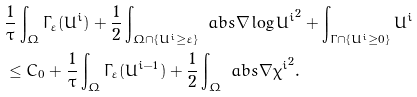Convert formula to latex. <formula><loc_0><loc_0><loc_500><loc_500>& \frac { 1 } { \tau } \int _ { \Omega } \Gamma _ { \varepsilon } ( U ^ { i } ) + \frac { 1 } { 2 } \int _ { \Omega \cap \{ U ^ { i } \geq \varepsilon \} } \ a b s { \nabla \log U ^ { i } } ^ { 2 } + \int _ { \Gamma \cap \{ U ^ { i } \geq 0 \} } U ^ { i } \\ & \leq C _ { 0 } + \frac { 1 } { \tau } \int _ { \Omega } \Gamma _ { \varepsilon } ( U ^ { i - 1 } ) + \frac { 1 } { 2 } \int _ { \Omega } \ a b s { \nabla \chi ^ { i } } ^ { 2 } .</formula> 